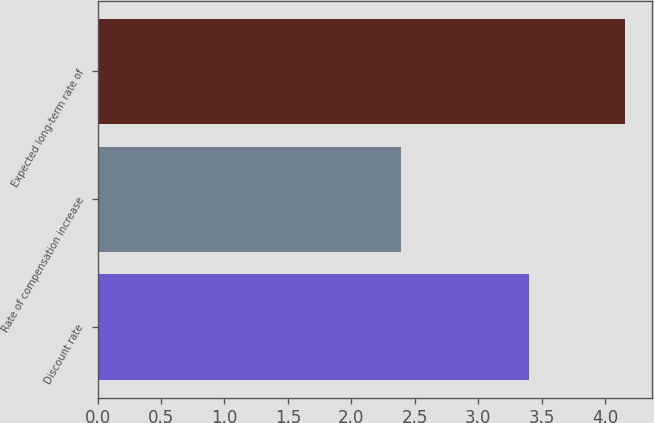Convert chart to OTSL. <chart><loc_0><loc_0><loc_500><loc_500><bar_chart><fcel>Discount rate<fcel>Rate of compensation increase<fcel>Expected long-term rate of<nl><fcel>3.4<fcel>2.39<fcel>4.16<nl></chart> 